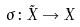<formula> <loc_0><loc_0><loc_500><loc_500>\sigma \colon \tilde { X } \rightarrow X</formula> 